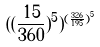Convert formula to latex. <formula><loc_0><loc_0><loc_500><loc_500>( ( \frac { 1 5 } { 3 6 0 } ) ^ { 5 } ) ^ { ( \frac { 3 2 6 } { 1 9 5 } ) ^ { 5 } }</formula> 